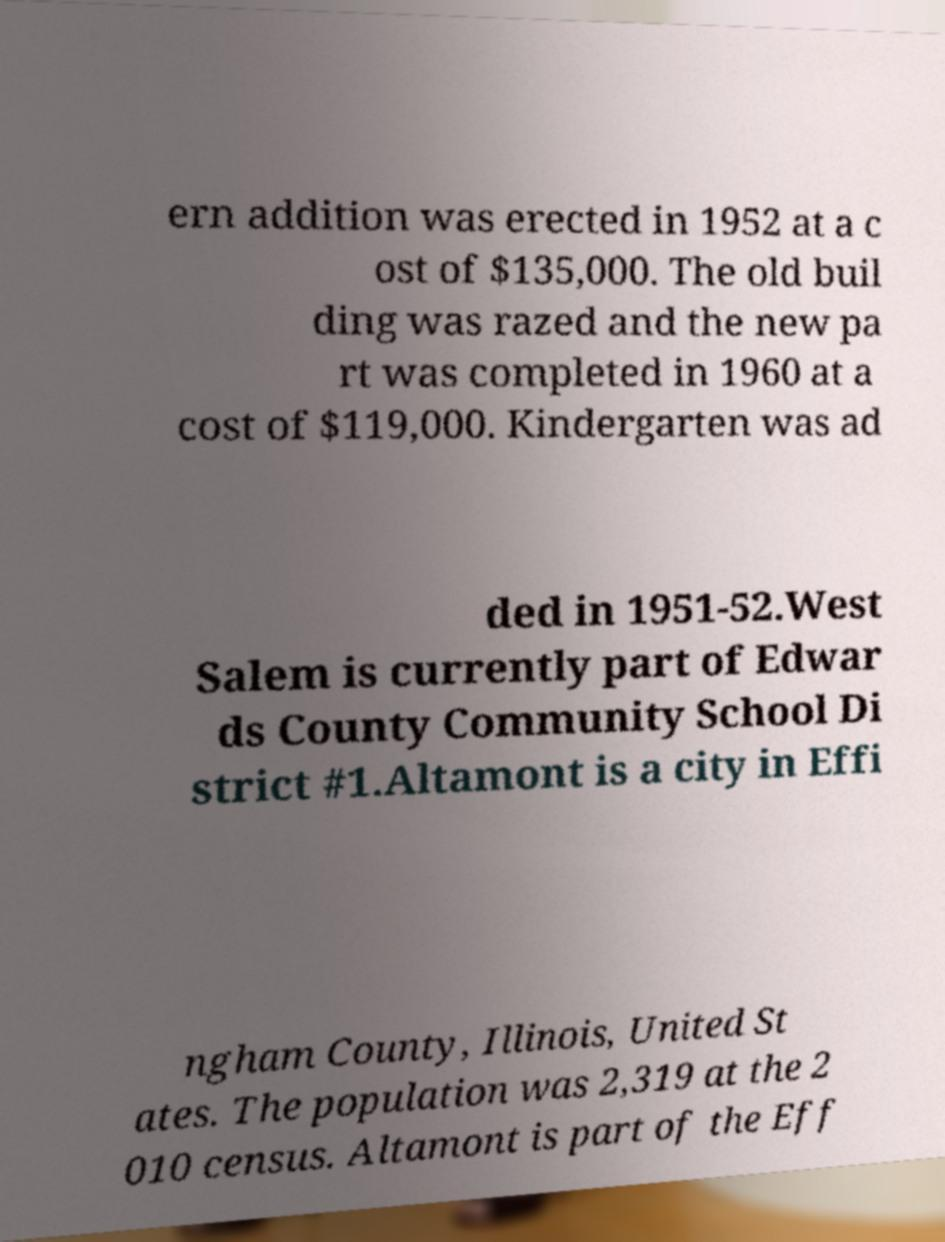I need the written content from this picture converted into text. Can you do that? ern addition was erected in 1952 at a c ost of $135,000. The old buil ding was razed and the new pa rt was completed in 1960 at a cost of $119,000. Kindergarten was ad ded in 1951-52.West Salem is currently part of Edwar ds County Community School Di strict #1.Altamont is a city in Effi ngham County, Illinois, United St ates. The population was 2,319 at the 2 010 census. Altamont is part of the Eff 